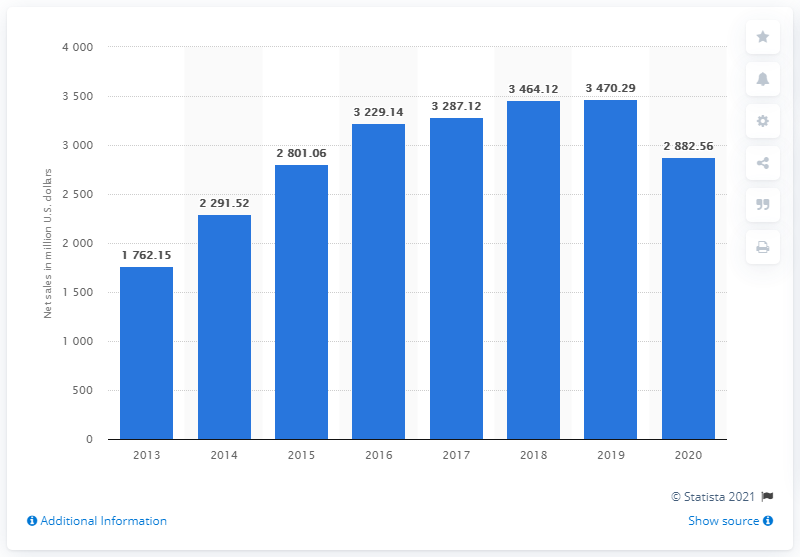List a handful of essential elements in this visual. In 2020, Under Armour generated approximately $2882.56 million from apparel sales. In 2020, Under Armour generated approximately 2.9 billion U.S. dollars from apparel sales. 